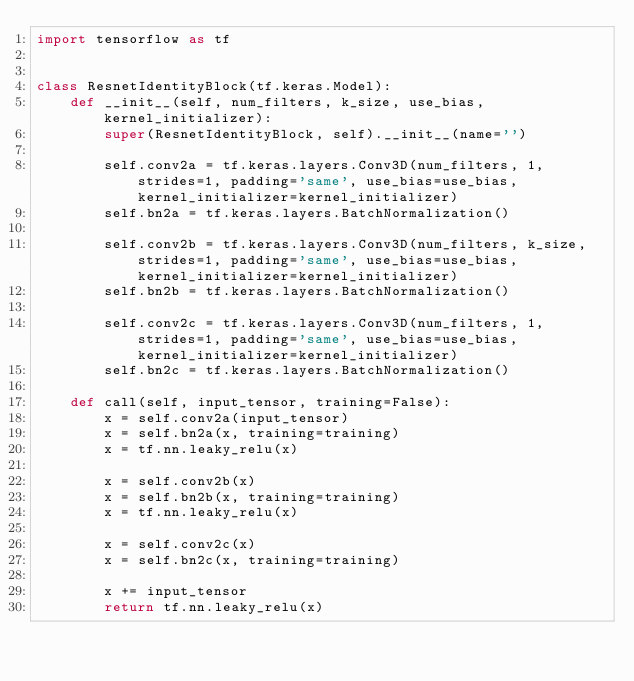Convert code to text. <code><loc_0><loc_0><loc_500><loc_500><_Python_>import tensorflow as tf


class ResnetIdentityBlock(tf.keras.Model):
    def __init__(self, num_filters, k_size, use_bias, kernel_initializer):
        super(ResnetIdentityBlock, self).__init__(name='')

        self.conv2a = tf.keras.layers.Conv3D(num_filters, 1, strides=1, padding='same', use_bias=use_bias, kernel_initializer=kernel_initializer)
        self.bn2a = tf.keras.layers.BatchNormalization()

        self.conv2b = tf.keras.layers.Conv3D(num_filters, k_size, strides=1, padding='same', use_bias=use_bias, kernel_initializer=kernel_initializer)
        self.bn2b = tf.keras.layers.BatchNormalization()

        self.conv2c = tf.keras.layers.Conv3D(num_filters, 1, strides=1, padding='same', use_bias=use_bias, kernel_initializer=kernel_initializer)
        self.bn2c = tf.keras.layers.BatchNormalization()

    def call(self, input_tensor, training=False):
        x = self.conv2a(input_tensor)
        x = self.bn2a(x, training=training)
        x = tf.nn.leaky_relu(x)

        x = self.conv2b(x)
        x = self.bn2b(x, training=training)
        x = tf.nn.leaky_relu(x)

        x = self.conv2c(x)
        x = self.bn2c(x, training=training)

        x += input_tensor
        return tf.nn.leaky_relu(x)
</code> 